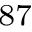Convert formula to latex. <formula><loc_0><loc_0><loc_500><loc_500>^ { 8 7 }</formula> 